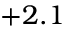Convert formula to latex. <formula><loc_0><loc_0><loc_500><loc_500>+ 2 . 1</formula> 